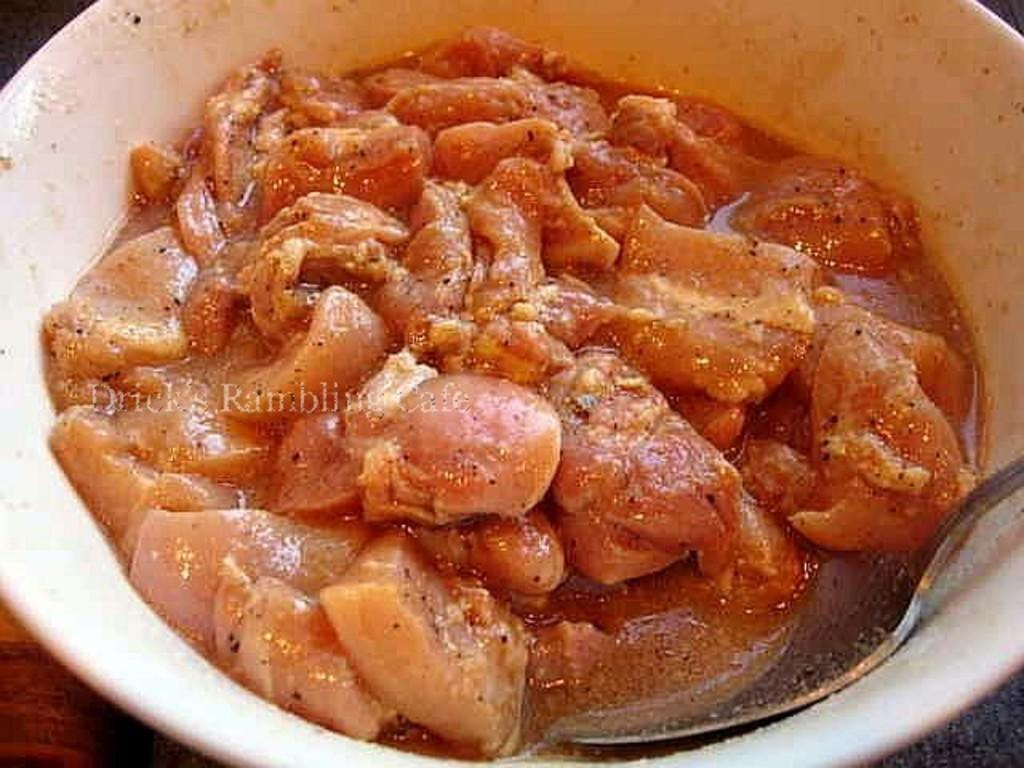What is the food item in the image? The specific food item is not mentioned, but there is a food item in the image. What utensil is present in the image? There is a spoon in the image. How is the spoon positioned in relation to the food item? The spoon is in a bowl. Where is the bowl located? The bowl is on a platform. What type of lamp is visible in the image? There is no lamp present in the image. What happens to the stone when the food item is consumed in the image? There is no stone mentioned in the image, and therefore no such interaction can be observed. 